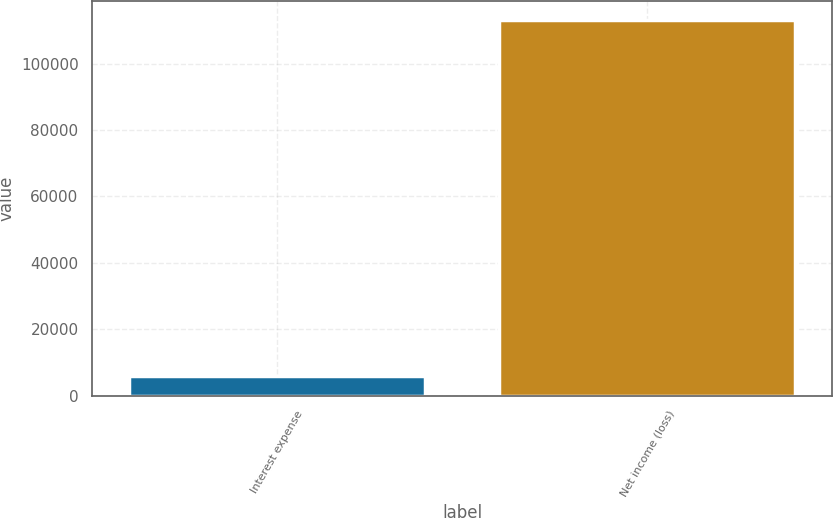<chart> <loc_0><loc_0><loc_500><loc_500><bar_chart><fcel>Interest expense<fcel>Net income (loss)<nl><fcel>5895<fcel>113241<nl></chart> 